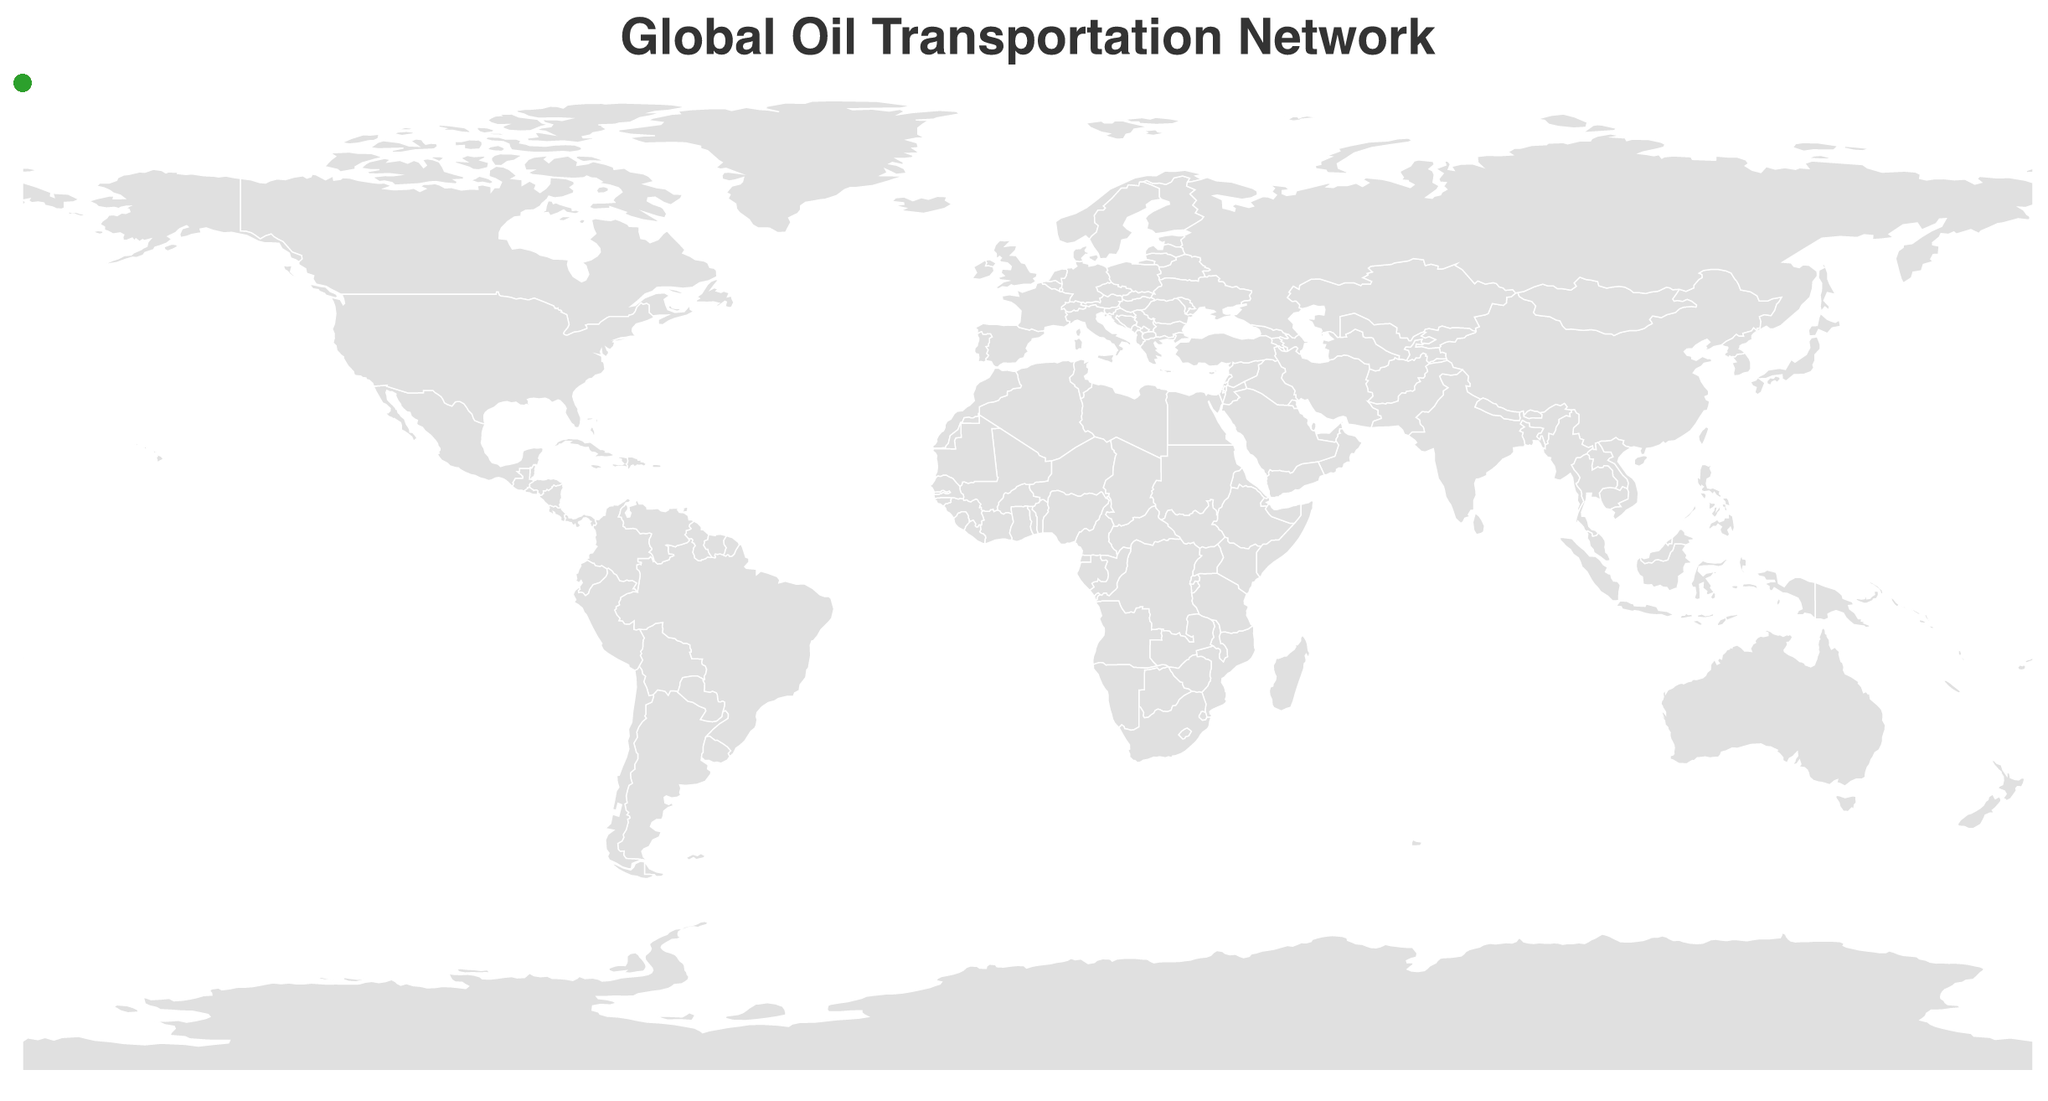What's the title of the figure? The title of the figure is usually presented at the top and is designed to provide a summary of the content. In this case, the title "Global Oil Transportation Network" is directly extracted from the figure.
Answer: Global Oil Transportation Network What types of transportation methods are illustrated in the figure? The figure differentiates between transportation methods using colors: orange represents pipelines and blue represents shipping routes. By examining the lines and their colors, we identify these two transportation methods.
Answer: Pipelines and Shipping Which pipeline has the longest length, and what is its length? To find the longest pipeline, we check the labels of the pipelines and their corresponding lengths. Here, the Druzhba Pipeline is the longest with a length of 4000 km.
Answer: Druzhba Pipeline, 4000 km Which has a greater total length: all pipelines or all shipping routes combined? Summing the lengths of all pipelines (1287 + 1900 + 3456 + 4000 + 1510 + 970 = 13123 km) and all shipping routes (11500 + 10200 + 16000 + 1800 + 12000 = 51500 km) shows that the total length of shipping routes is greater.
Answer: Shipping routes Identify the longest shipping route and its length. Looking at the shipping routes and their lengths, the Caribbean-East Asia Route stands out as the longest with 16000 km.
Answer: Caribbean-East Asia Route, 16000 km Which origin point is associated with the largest number of destinations? Observing the origin points, we notice that each pipeline or shipping route has different origin points, meaning there is no single origin with multiple destinations in the provided data.
Answer: None Compare the length of the Enbridge Mainline and the Keystone Pipeline, and state which is longer. Comparing the respective lengths of the Enbridge Mainline (1900 km) and the Keystone Pipeline (3456 km) reveals that the Keystone Pipeline is longer.
Answer: Keystone Pipeline How does the map illustrate the route types differently? The map uses color to differentiate route types: orange for pipelines and blue for shipping routes. It also varies stroke width to represent the length of the routes and places circles at origin and destination points.
Answer: Color and stroke width What is the shortest route depicted, and what transportation method does it use? By examining the lengths of both pipelines and shipping routes, the shortest route is the Kirkuk-Ceyhan Pipeline with 970 km, making it a pipeline transportation method.
Answer: Kirkuk-Ceyhan Pipeline, Pipeline 